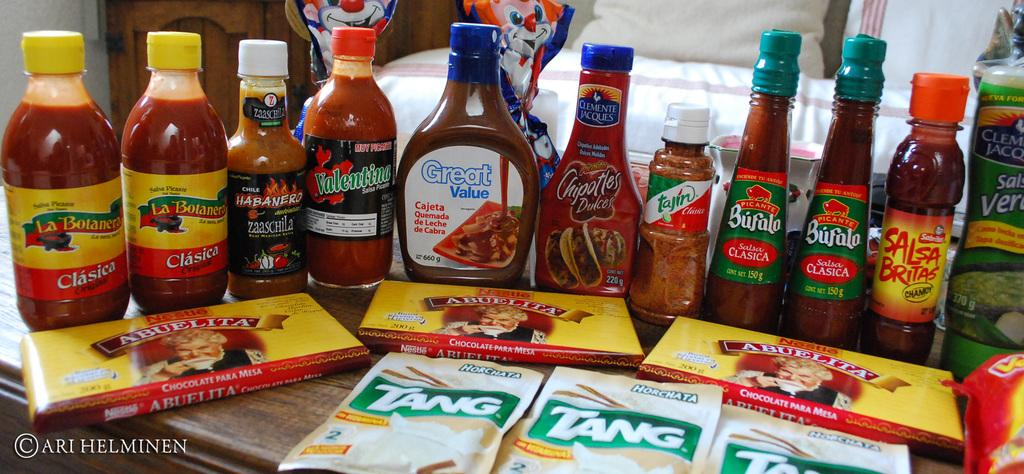What type of furniture is visible in the image? There is a table in the image. What is placed on the table? Bottles are placed on the table. What accompanies the bottles on the table? There are food items and powders in front of the bottles. What is the purpose of the protest happening outside the door in the image? There is no door or protest present in the image; it only features a table with bottles, food items, and powders. 